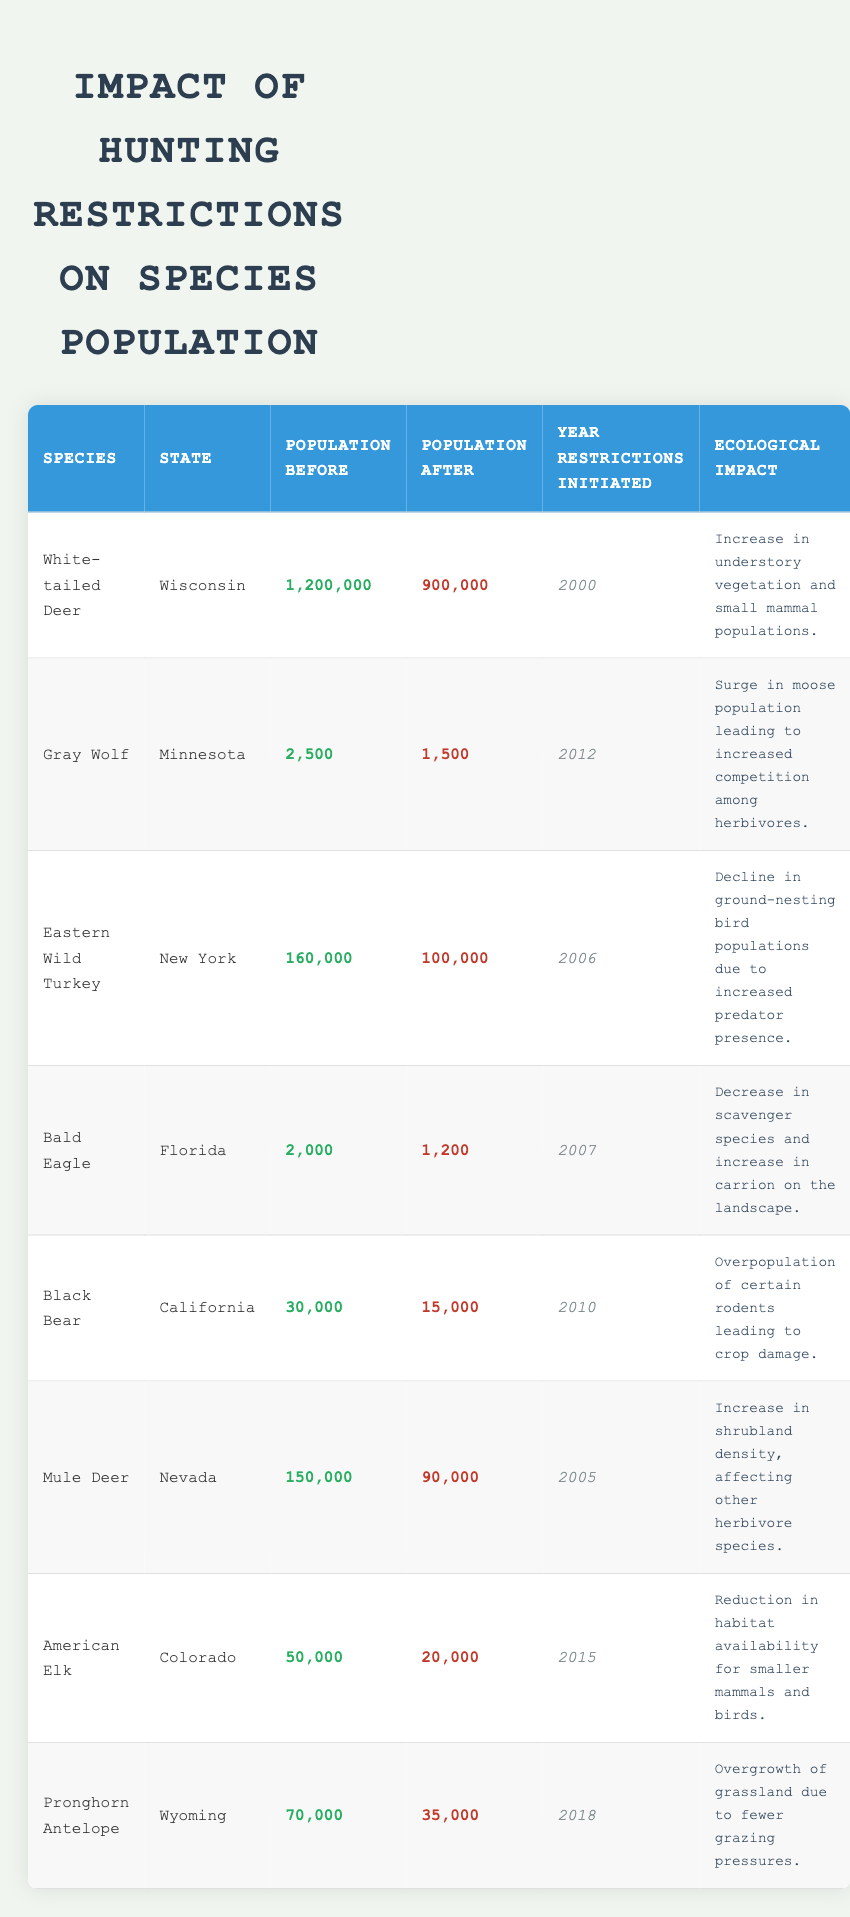What was the population of White-tailed Deer in Wisconsin before restrictions? According to the table, the population of White-tailed Deer in Wisconsin before restrictions was 1,200,000.
Answer: 1,200,000 What year were hunting restrictions initiated for the Gray Wolf in Minnesota? The table indicates that hunting restrictions for the Gray Wolf were initiated in the year 2012.
Answer: 2012 How many species had a population decrease after hunting restrictions were implemented? By examining the table, we see that all listed species except for the White-tailed Deer experienced a population decrease, totaling 7 species.
Answer: 7 What is the difference in population of the Eastern Wild Turkey before and after restrictions? The population before restrictions was 160,000 and after was 100,000. The difference is calculated as 160,000 - 100,000 = 60,000.
Answer: 60,000 Which species saw a decrease in scavenger species and an increase in carrion on the landscape due to hunting restrictions? The table lists the Bald Eagle as the species experiencing this particular ecological impact.
Answer: Bald Eagle What was the combined population of Black Bear and American Elk before restrictions? The Black Bear population was 30,000 and the American Elk population was 50,000. The combined population is 30,000 + 50,000 = 80,000.
Answer: 80,000 Did the population of the Pronghorn Antelope increase or decrease after hunting restrictions? The table shows that the population of Pronghorn Antelope decreased from 70,000 to 35,000 after hunting restrictions.
Answer: Decrease Which species had the lowest population after restrictions? After looking at the table, the species with the lowest population after restrictions is the Bald Eagle with a population of 1,200.
Answer: 1,200 What ecological impact is associated with the decline in the Black Bear population in California? The Black Bear's decline has resulted in overpopulation of certain rodents, leading to crop damage according to the table.
Answer: Overpopulation of rodents If we consider just the states with a population greater than 100,000 before restrictions, how many species are there? Looking at the populations before restrictions, only the White-tailed Deer (1,200,000) and Eastern Wild Turkey (160,000) exceed 100,000. Thus, there are 2 species that meet the criteria.
Answer: 2 